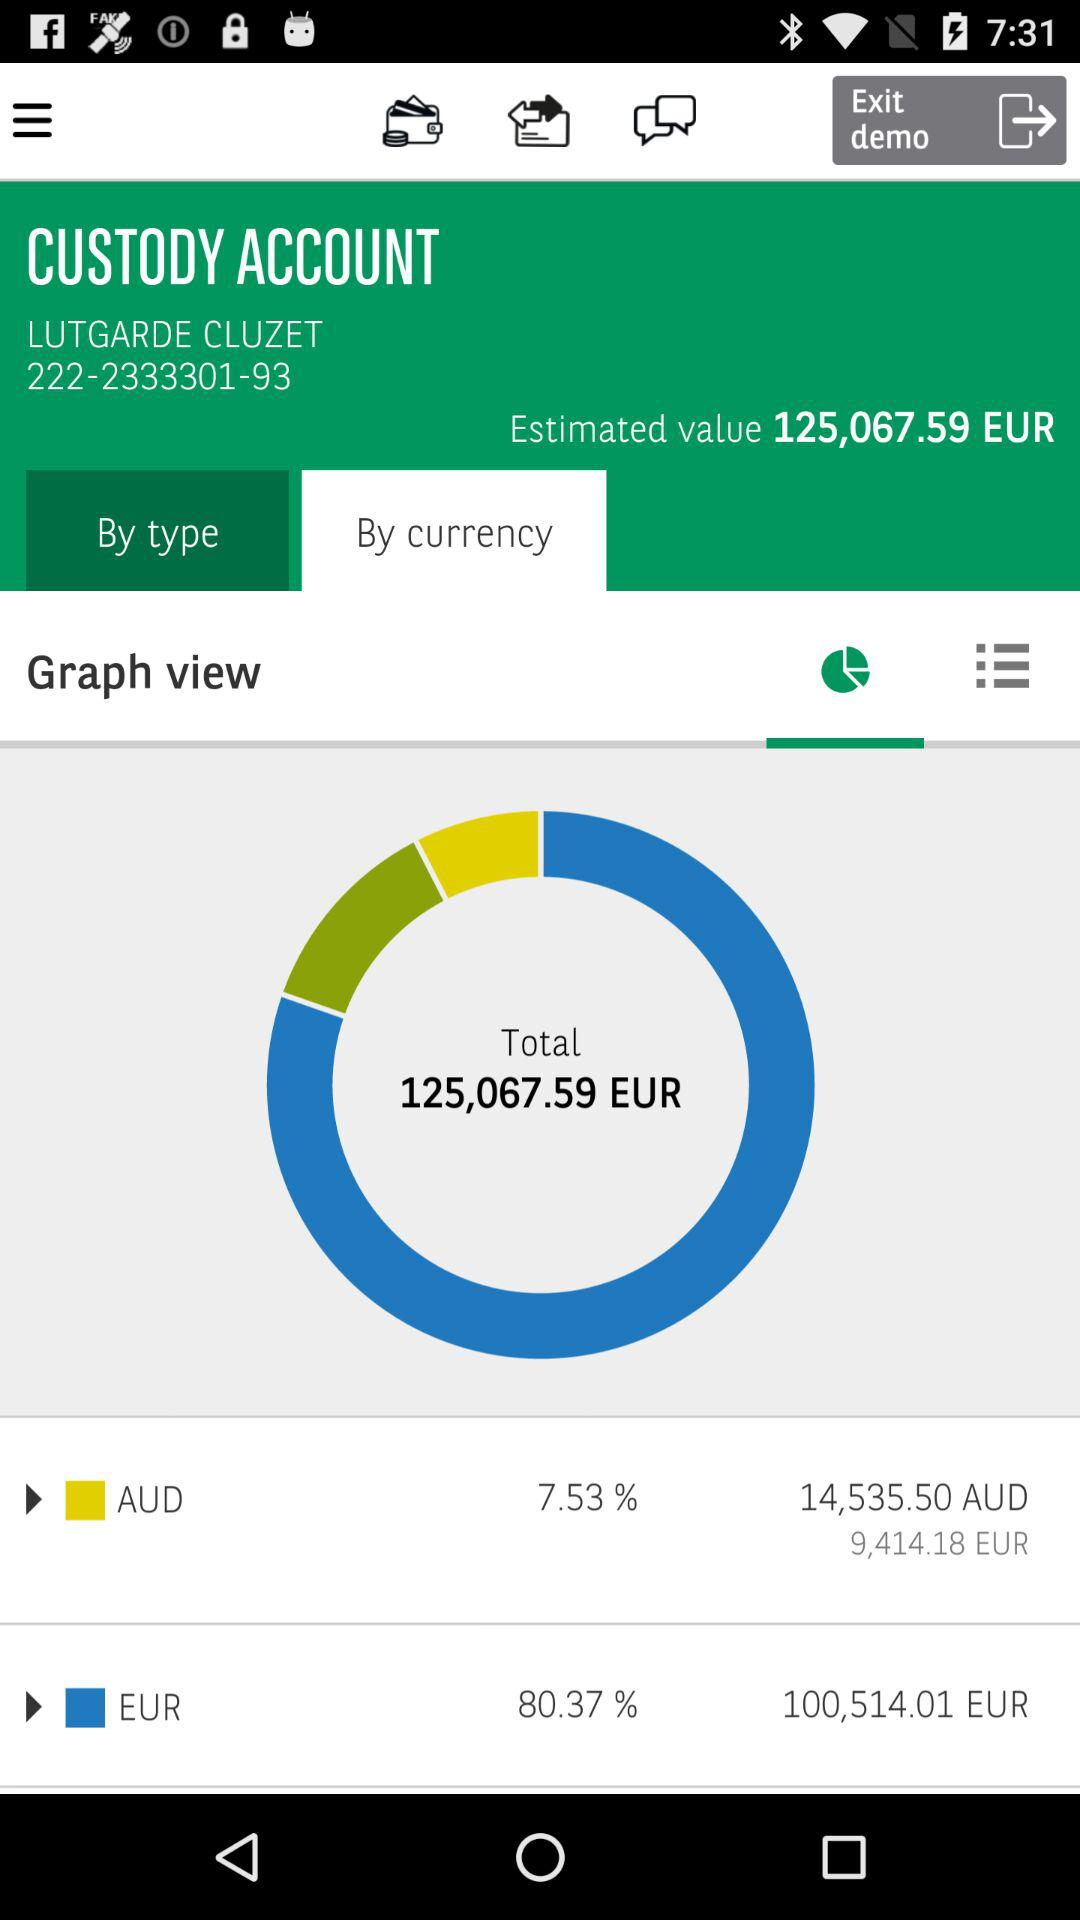What is the percentage of the total value that is in AUD?
Answer the question using a single word or phrase. 7.53% 